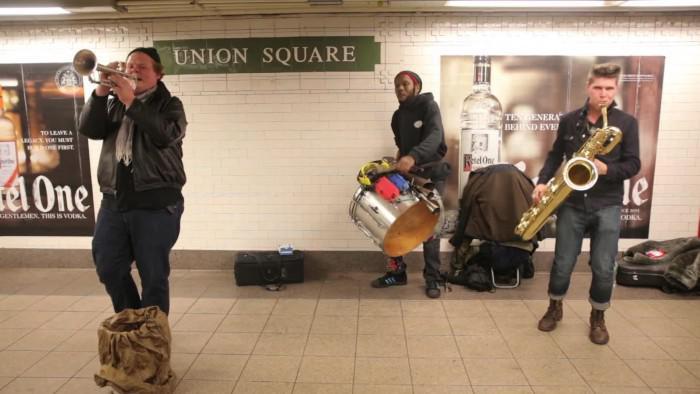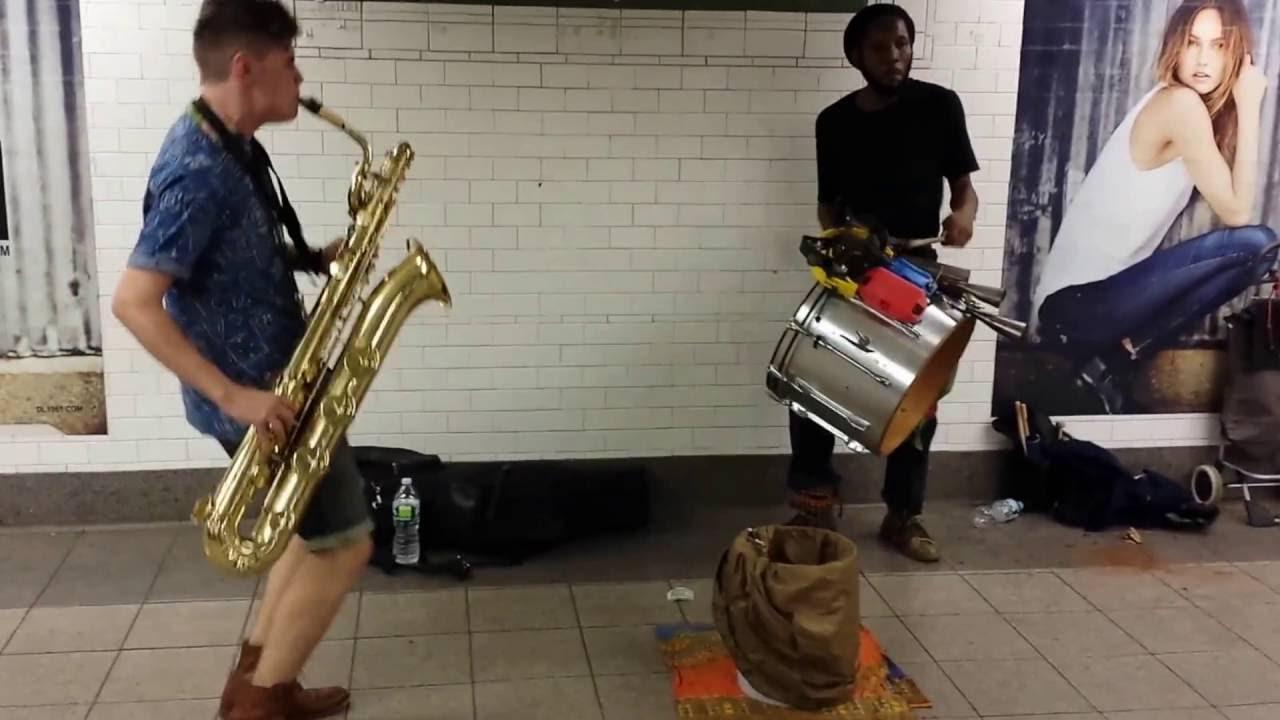The first image is the image on the left, the second image is the image on the right. For the images displayed, is the sentence "The right image includes a sax player, drummer and horn player standing in a station with images of liquor bottles behind them and a bucket-type container on the floor by them." factually correct? Answer yes or no. No. 